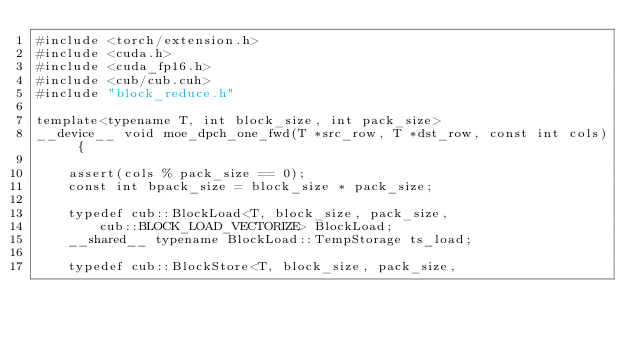<code> <loc_0><loc_0><loc_500><loc_500><_Cuda_>#include <torch/extension.h>
#include <cuda.h>
#include <cuda_fp16.h>
#include <cub/cub.cuh>
#include "block_reduce.h"

template<typename T, int block_size, int pack_size>
__device__ void moe_dpch_one_fwd(T *src_row, T *dst_row, const int cols) {

    assert(cols % pack_size == 0);
    const int bpack_size = block_size * pack_size;

    typedef cub::BlockLoad<T, block_size, pack_size,
        cub::BLOCK_LOAD_VECTORIZE> BlockLoad;
    __shared__ typename BlockLoad::TempStorage ts_load;

    typedef cub::BlockStore<T, block_size, pack_size,</code> 